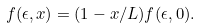<formula> <loc_0><loc_0><loc_500><loc_500>f ( \epsilon , x ) = ( 1 - x / L ) f ( \epsilon , 0 ) .</formula> 